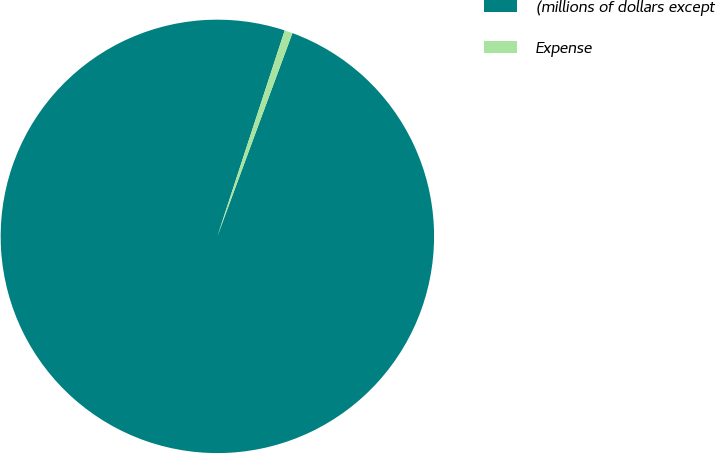Convert chart. <chart><loc_0><loc_0><loc_500><loc_500><pie_chart><fcel>(millions of dollars except<fcel>Expense<nl><fcel>99.4%<fcel>0.6%<nl></chart> 